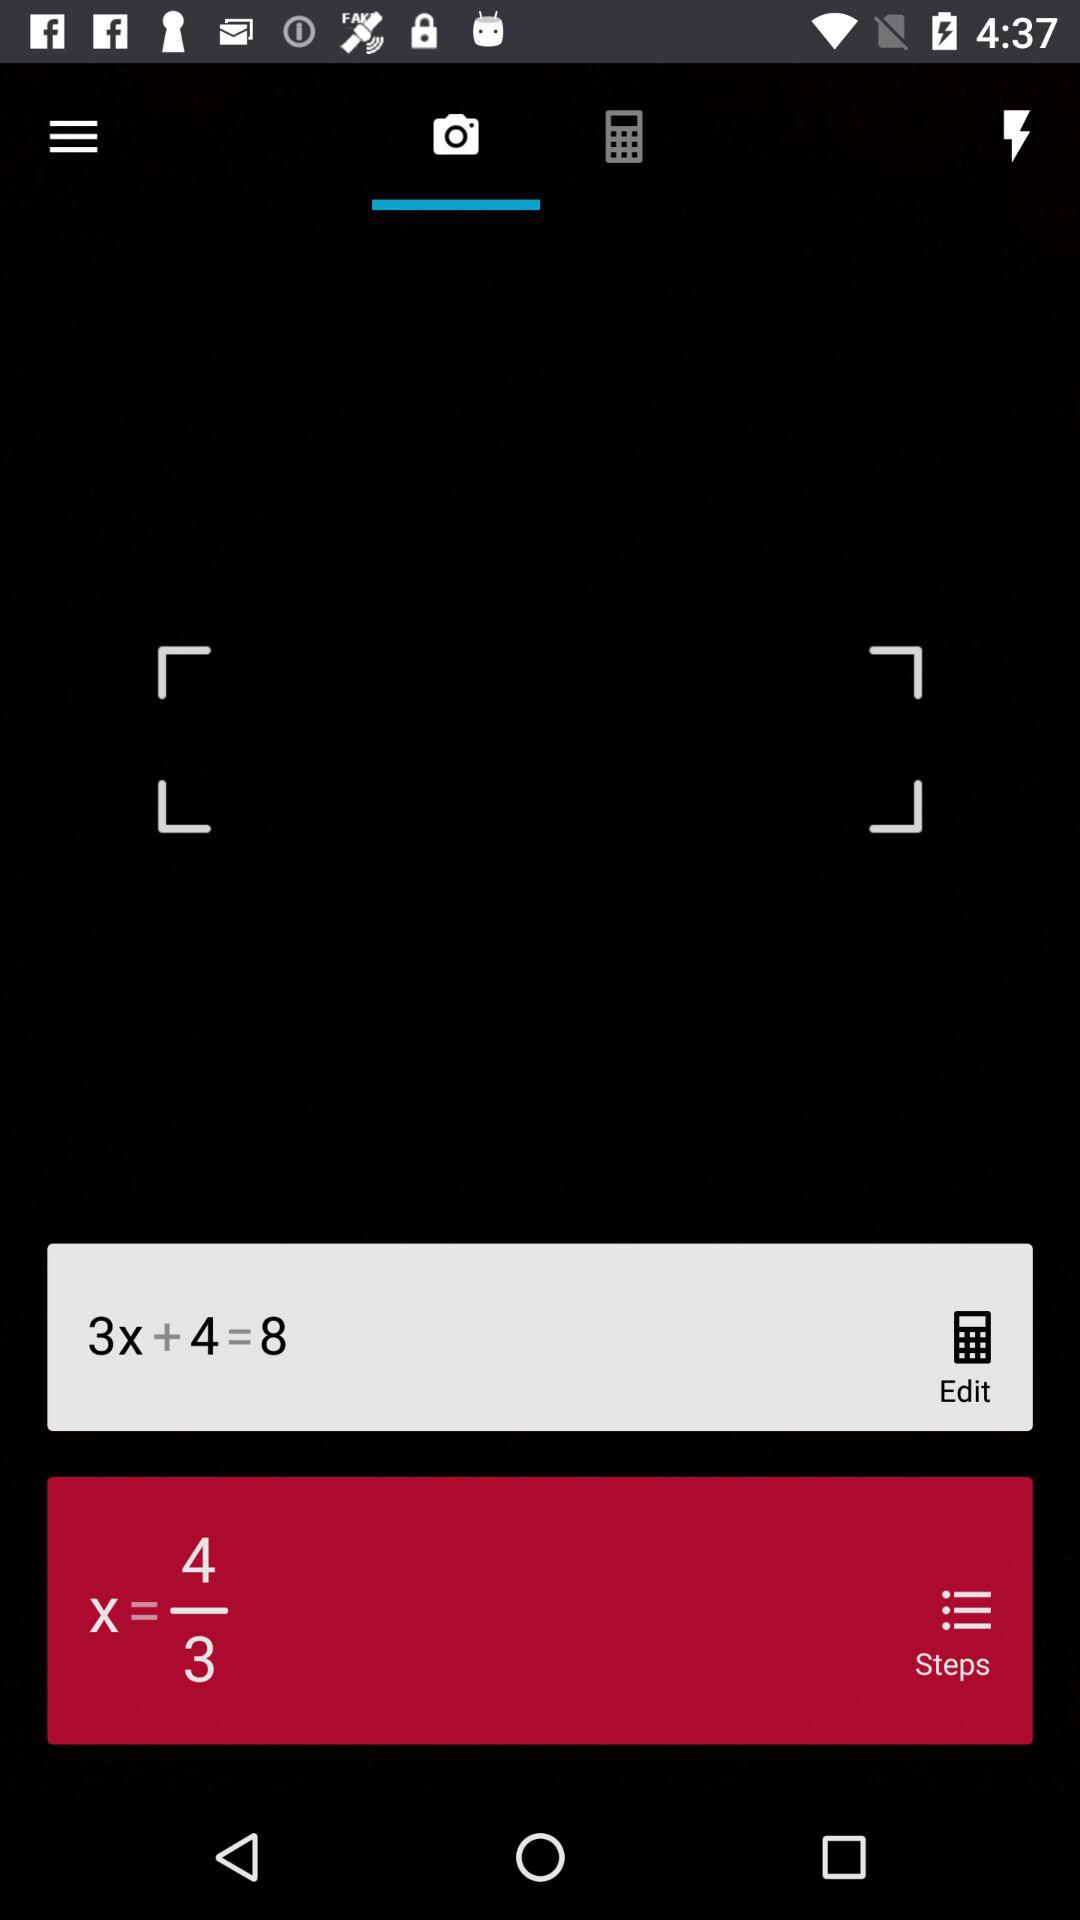What is the solution to the equation?
Answer the question using a single word or phrase. 2 